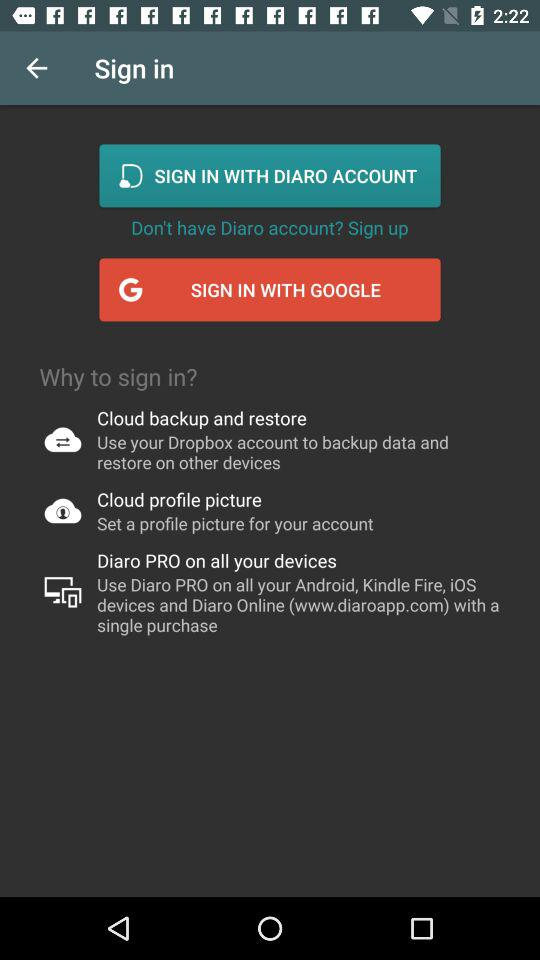Where can "Diaro" PRO be used? You can use "Diaro" PRO on all your Android, Kindle Fire, iOS devices and Diaro online (www.diaroapp.com) with a single purchase. 